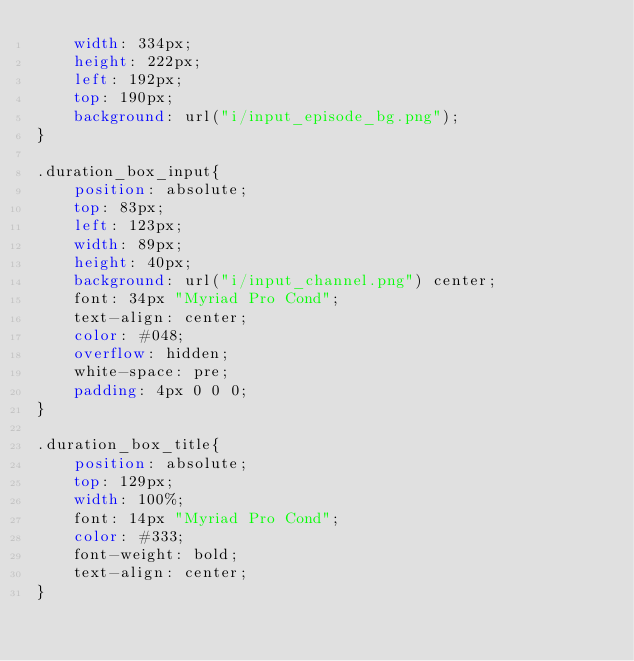Convert code to text. <code><loc_0><loc_0><loc_500><loc_500><_CSS_>    width: 334px;
    height: 222px;
    left: 192px;
    top: 190px;
    background: url("i/input_episode_bg.png");
}

.duration_box_input{
    position: absolute;
    top: 83px;
    left: 123px;
    width: 89px;
    height: 40px;
    background: url("i/input_channel.png") center;
    font: 34px "Myriad Pro Cond";
    text-align: center;
    color: #048;
    overflow: hidden;
    white-space: pre;
    padding: 4px 0 0 0;
}

.duration_box_title{
    position: absolute;
    top: 129px;
    width: 100%;
    font: 14px "Myriad Pro Cond";
    color: #333;
    font-weight: bold;
    text-align: center;
}</code> 